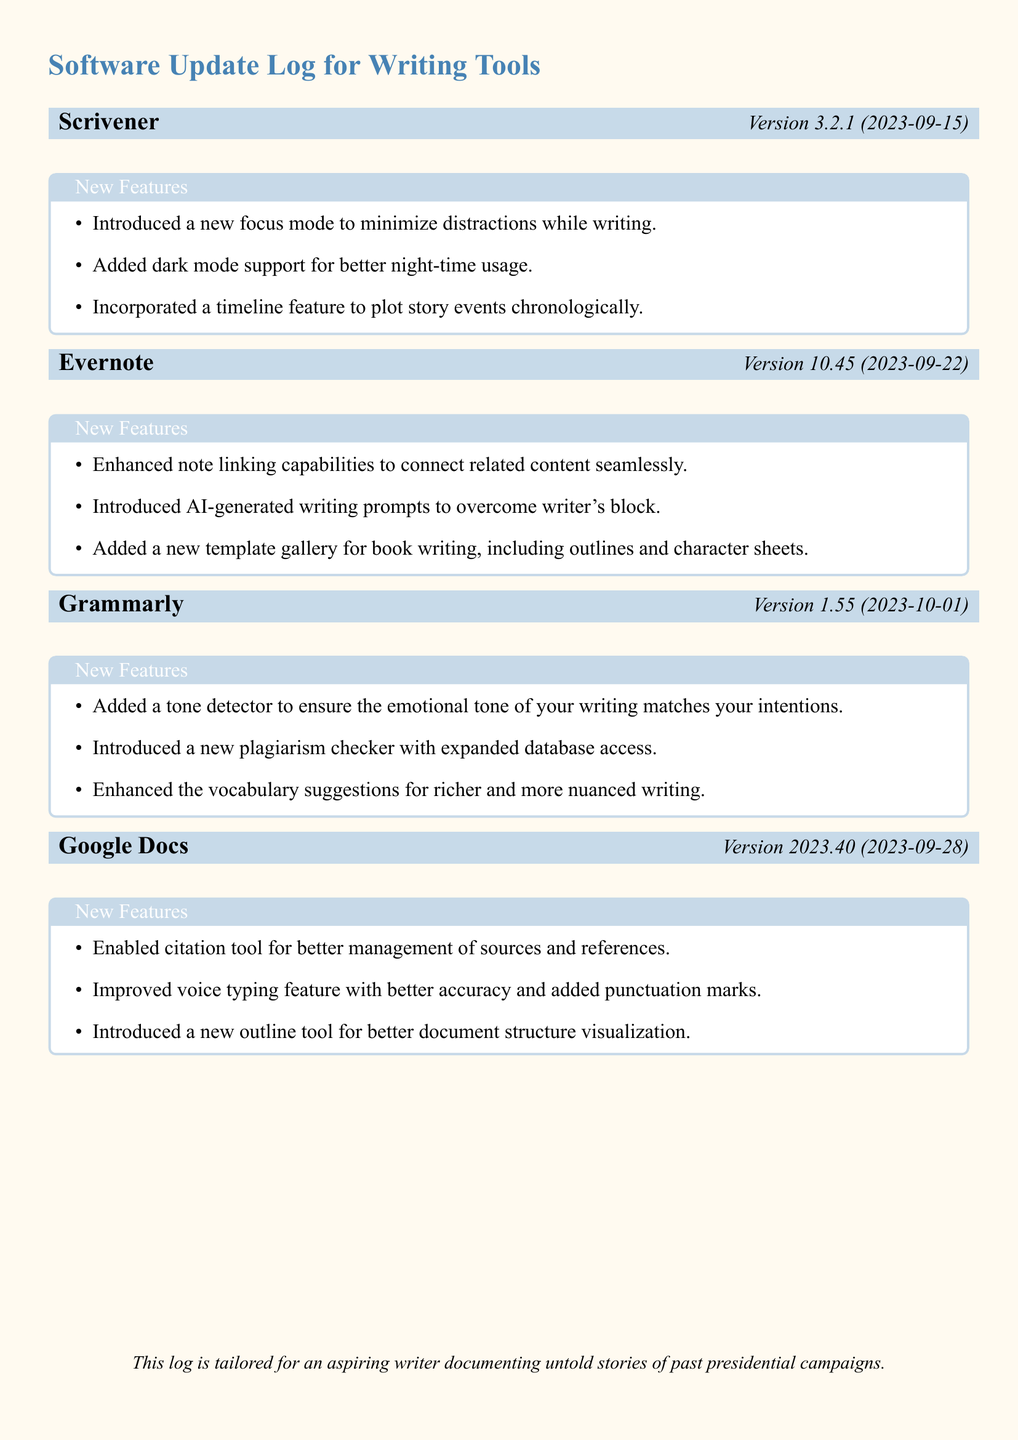What is the version number for Scrivener? The version number for Scrivener is listed in the header of the section dedicated to it.
Answer: 3.2.1 What new feature was added in Evernote? New features are detailed in the tcolorbox for Evernote, listing enhancements and additions.
Answer: Enhanced note linking capabilities What date was Grammarly updated? The update date is part of the header for the Grammarly section.
Answer: 2023-10-01 How many new features were introduced in Google Docs? The number of new features is found by counting the list items in the Google Docs section.
Answer: Three Which application added a tone detector? Features are distinctly laid out under each application, indicating which features belong to which app.
Answer: Grammarly What is the latest version of Evernote? The latest version information is included in the app header associated with Evernote.
Answer: 10.45 What feature does Scrivener's focus mode minimize? The focus mode's purpose is specified in its feature description within its section.
Answer: Distractions Which application added AI-generated writing prompts? The addition of writing prompts is specifically mentioned in the new features for a particular application.
Answer: Evernote What is the structure improvement tool introduced in Google Docs? The outline tool is listed under the new features for Google Docs, indicating its purpose.
Answer: Outline tool 